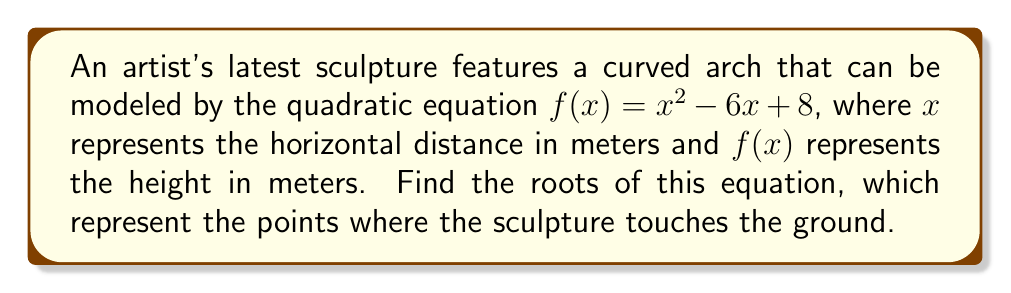Teach me how to tackle this problem. To find the roots of the quadratic equation, we need to solve $f(x) = 0$:

1) Set the equation equal to zero:
   $x^2 - 6x + 8 = 0$

2) This quadratic equation is in the standard form $ax^2 + bx + c = 0$, where:
   $a = 1$, $b = -6$, and $c = 8$

3) We can solve this using the quadratic formula: $x = \frac{-b \pm \sqrt{b^2 - 4ac}}{2a}$

4) Substituting our values:
   $x = \frac{-(-6) \pm \sqrt{(-6)^2 - 4(1)(8)}}{2(1)}$

5) Simplify:
   $x = \frac{6 \pm \sqrt{36 - 32}}{2} = \frac{6 \pm \sqrt{4}}{2} = \frac{6 \pm 2}{2}$

6) This gives us two solutions:
   $x_1 = \frac{6 + 2}{2} = 4$ and $x_2 = \frac{6 - 2}{2} = 2$

Therefore, the roots of the equation are 2 and 4, meaning the sculpture touches the ground at 2 meters and 4 meters from the origin.
Answer: $x = 2$ and $x = 4$ 